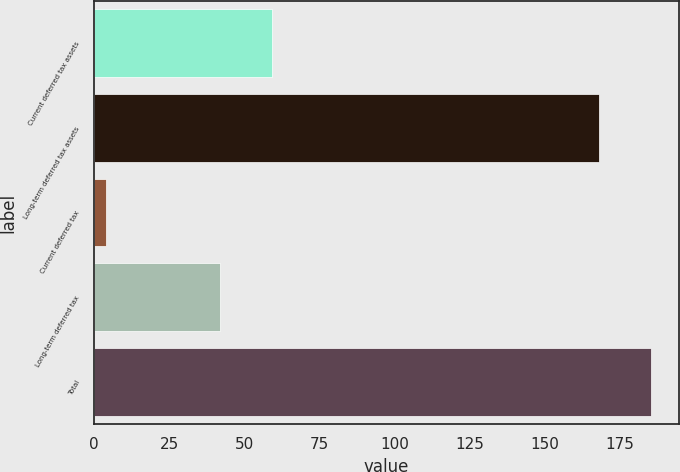Convert chart. <chart><loc_0><loc_0><loc_500><loc_500><bar_chart><fcel>Current deferred tax assets<fcel>Long-term deferred tax assets<fcel>Current deferred tax<fcel>Long-term deferred tax<fcel>Total<nl><fcel>59.2<fcel>168<fcel>4<fcel>42<fcel>185.2<nl></chart> 